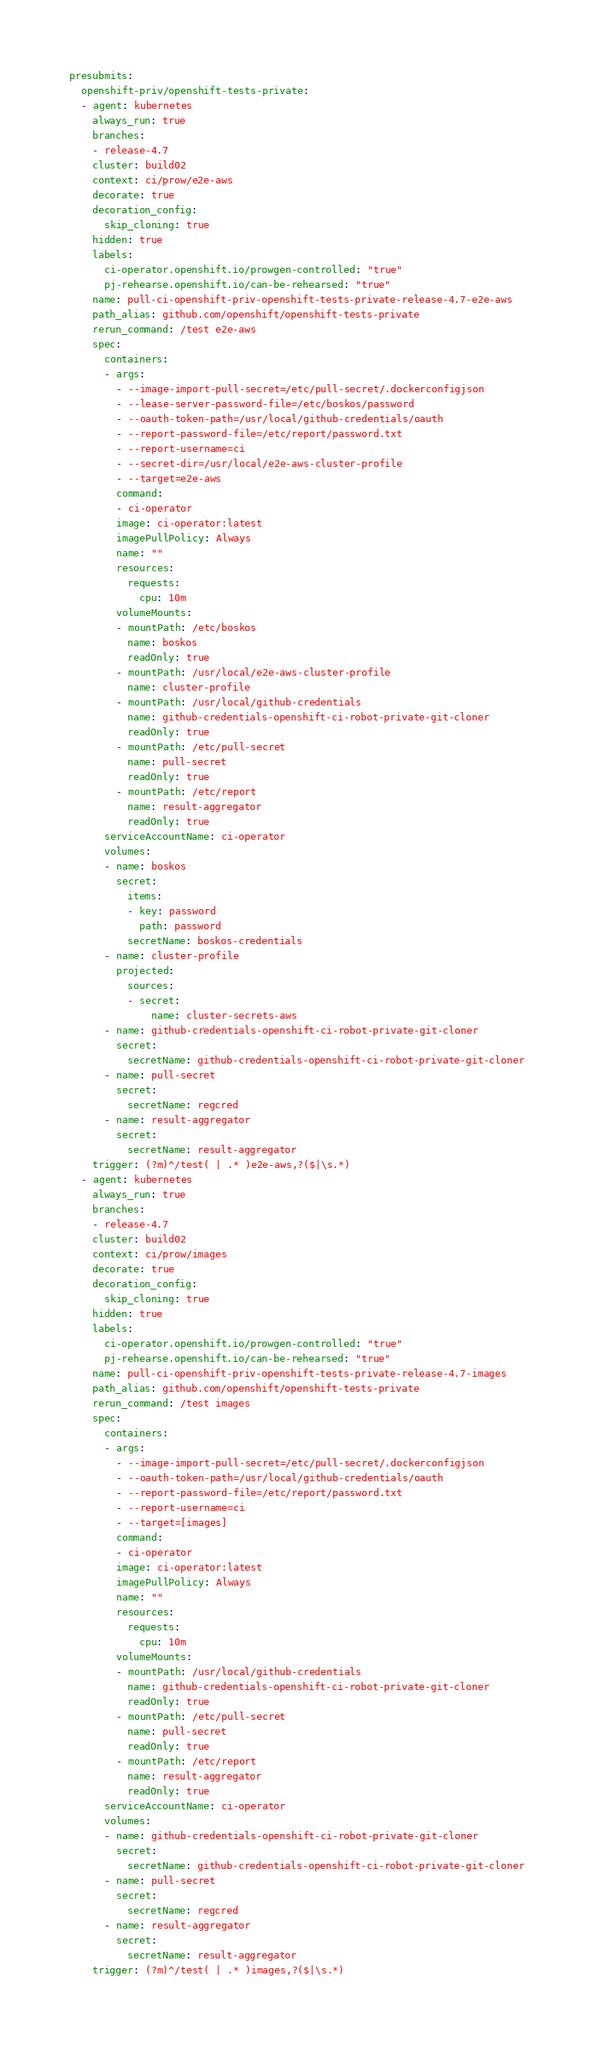<code> <loc_0><loc_0><loc_500><loc_500><_YAML_>presubmits:
  openshift-priv/openshift-tests-private:
  - agent: kubernetes
    always_run: true
    branches:
    - release-4.7
    cluster: build02
    context: ci/prow/e2e-aws
    decorate: true
    decoration_config:
      skip_cloning: true
    hidden: true
    labels:
      ci-operator.openshift.io/prowgen-controlled: "true"
      pj-rehearse.openshift.io/can-be-rehearsed: "true"
    name: pull-ci-openshift-priv-openshift-tests-private-release-4.7-e2e-aws
    path_alias: github.com/openshift/openshift-tests-private
    rerun_command: /test e2e-aws
    spec:
      containers:
      - args:
        - --image-import-pull-secret=/etc/pull-secret/.dockerconfigjson
        - --lease-server-password-file=/etc/boskos/password
        - --oauth-token-path=/usr/local/github-credentials/oauth
        - --report-password-file=/etc/report/password.txt
        - --report-username=ci
        - --secret-dir=/usr/local/e2e-aws-cluster-profile
        - --target=e2e-aws
        command:
        - ci-operator
        image: ci-operator:latest
        imagePullPolicy: Always
        name: ""
        resources:
          requests:
            cpu: 10m
        volumeMounts:
        - mountPath: /etc/boskos
          name: boskos
          readOnly: true
        - mountPath: /usr/local/e2e-aws-cluster-profile
          name: cluster-profile
        - mountPath: /usr/local/github-credentials
          name: github-credentials-openshift-ci-robot-private-git-cloner
          readOnly: true
        - mountPath: /etc/pull-secret
          name: pull-secret
          readOnly: true
        - mountPath: /etc/report
          name: result-aggregator
          readOnly: true
      serviceAccountName: ci-operator
      volumes:
      - name: boskos
        secret:
          items:
          - key: password
            path: password
          secretName: boskos-credentials
      - name: cluster-profile
        projected:
          sources:
          - secret:
              name: cluster-secrets-aws
      - name: github-credentials-openshift-ci-robot-private-git-cloner
        secret:
          secretName: github-credentials-openshift-ci-robot-private-git-cloner
      - name: pull-secret
        secret:
          secretName: regcred
      - name: result-aggregator
        secret:
          secretName: result-aggregator
    trigger: (?m)^/test( | .* )e2e-aws,?($|\s.*)
  - agent: kubernetes
    always_run: true
    branches:
    - release-4.7
    cluster: build02
    context: ci/prow/images
    decorate: true
    decoration_config:
      skip_cloning: true
    hidden: true
    labels:
      ci-operator.openshift.io/prowgen-controlled: "true"
      pj-rehearse.openshift.io/can-be-rehearsed: "true"
    name: pull-ci-openshift-priv-openshift-tests-private-release-4.7-images
    path_alias: github.com/openshift/openshift-tests-private
    rerun_command: /test images
    spec:
      containers:
      - args:
        - --image-import-pull-secret=/etc/pull-secret/.dockerconfigjson
        - --oauth-token-path=/usr/local/github-credentials/oauth
        - --report-password-file=/etc/report/password.txt
        - --report-username=ci
        - --target=[images]
        command:
        - ci-operator
        image: ci-operator:latest
        imagePullPolicy: Always
        name: ""
        resources:
          requests:
            cpu: 10m
        volumeMounts:
        - mountPath: /usr/local/github-credentials
          name: github-credentials-openshift-ci-robot-private-git-cloner
          readOnly: true
        - mountPath: /etc/pull-secret
          name: pull-secret
          readOnly: true
        - mountPath: /etc/report
          name: result-aggregator
          readOnly: true
      serviceAccountName: ci-operator
      volumes:
      - name: github-credentials-openshift-ci-robot-private-git-cloner
        secret:
          secretName: github-credentials-openshift-ci-robot-private-git-cloner
      - name: pull-secret
        secret:
          secretName: regcred
      - name: result-aggregator
        secret:
          secretName: result-aggregator
    trigger: (?m)^/test( | .* )images,?($|\s.*)
</code> 